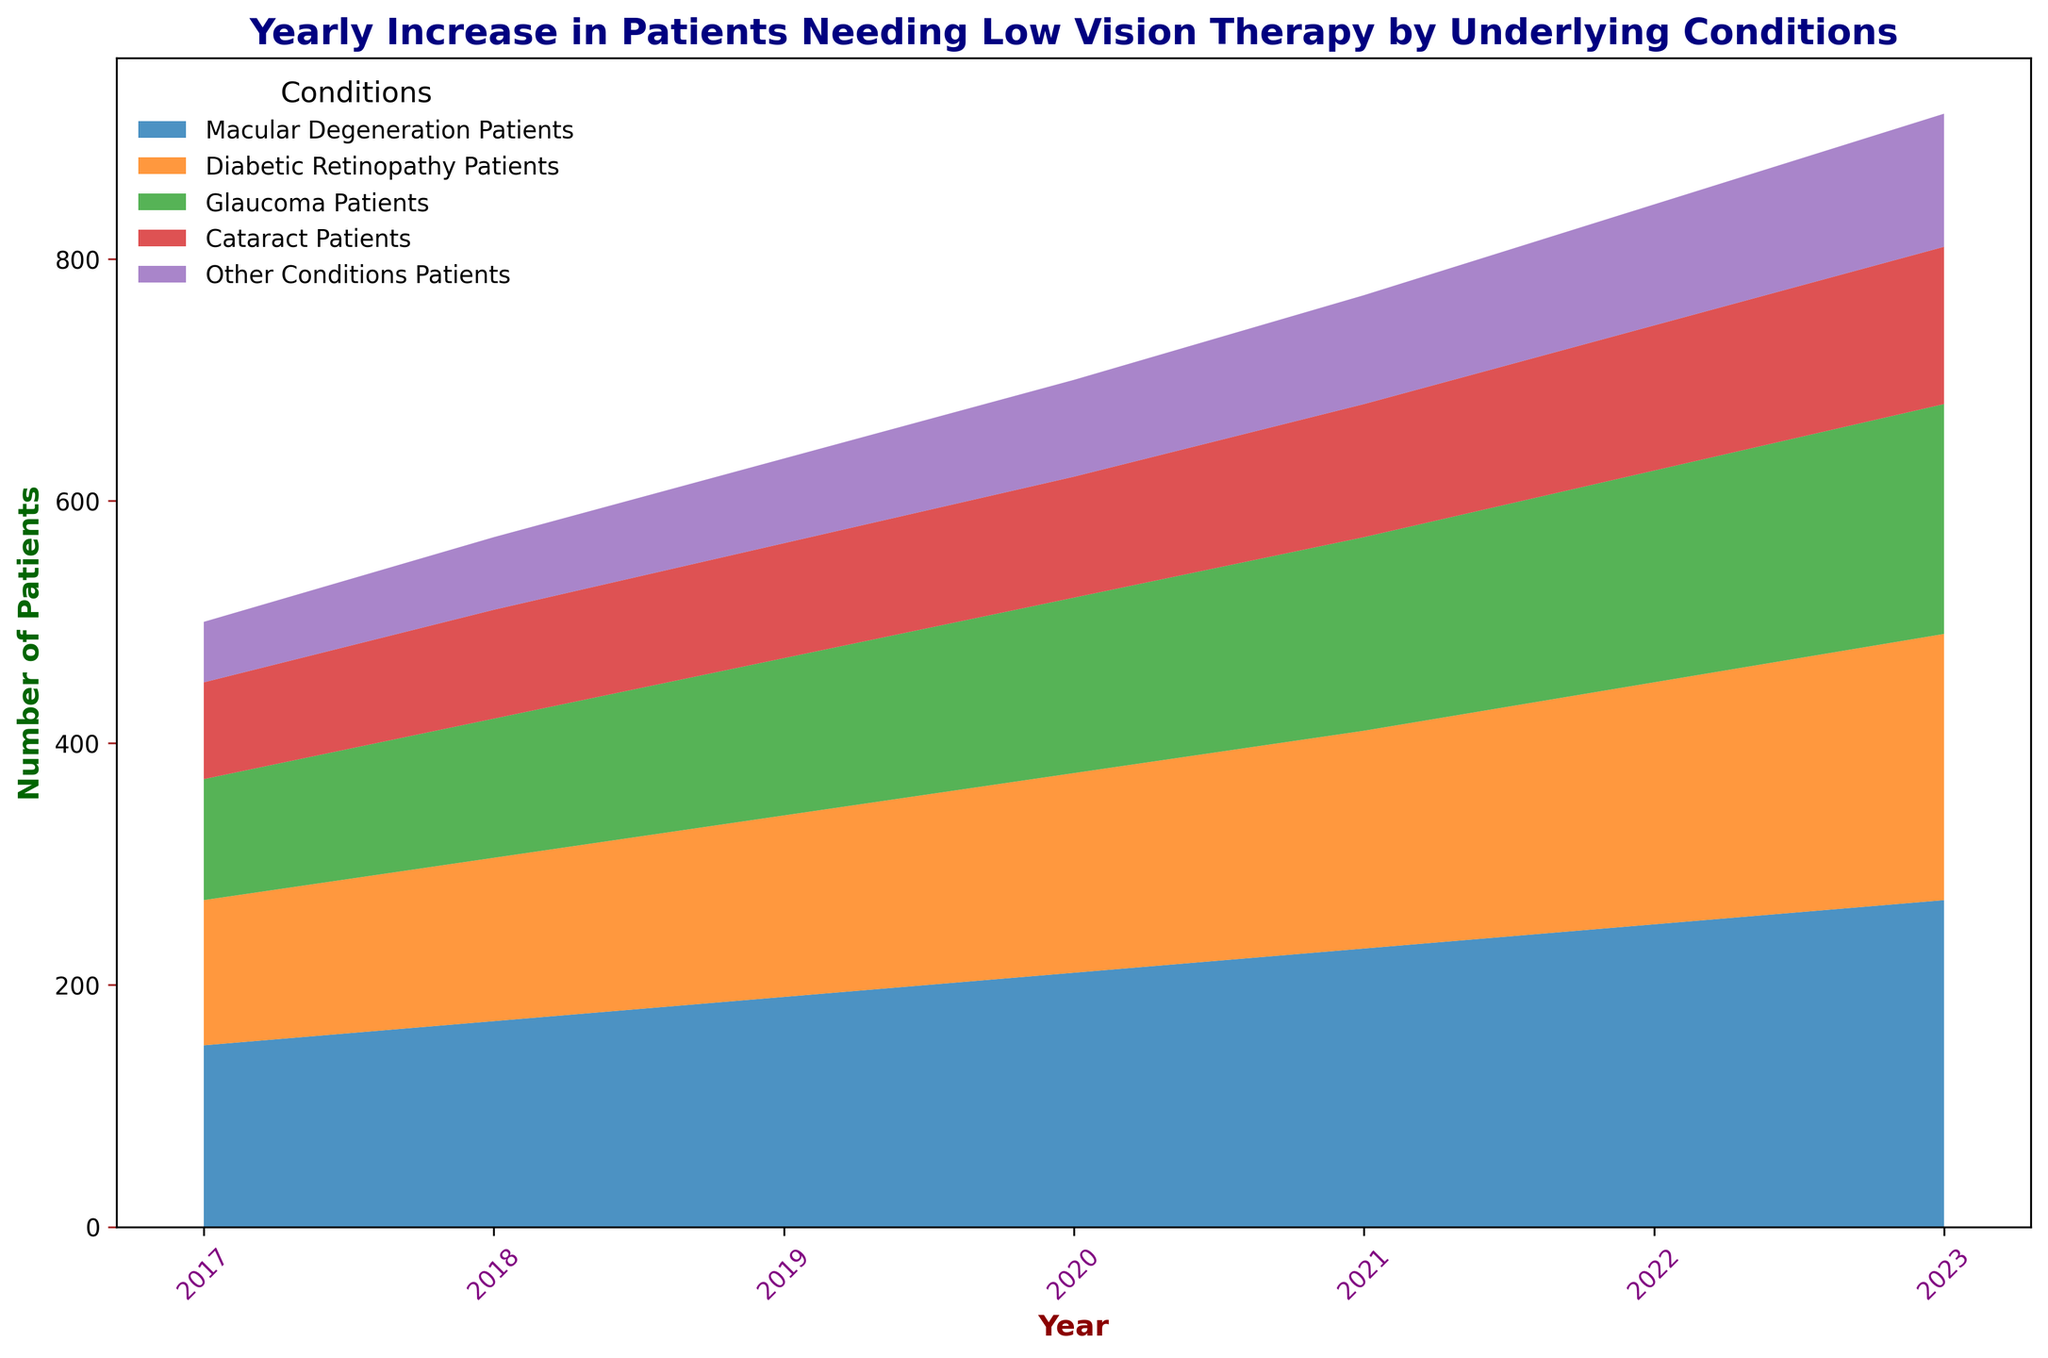What is the total number of patients needing low vision therapy in 2023 across all conditions? To find the total number in 2023, sum the patient numbers for each condition: Macular Degeneration (270) + Diabetic Retinopathy (220) + Glaucoma (190) + Cataract (130) + Other Conditions (110). So, the total is 270+220+190+130+110=920.
Answer: 920 Which condition saw the highest increase in the number of patients from 2017 to 2023? Calculate the difference in patient numbers for each condition between 2017 and 2023: Macular Degeneration (270-150=120), Diabetic Retinopathy (220-120=100), Glaucoma (190-100=90), Cataract (130-80=50), Other Conditions (110-50=60). The highest increase is for Macular Degeneration with 120 patients.
Answer: Macular Degeneration Between which years did the number of Cataract patients increase the most? Compare the yearly increments for Cataract patients: 2018 (90-80=10), 2019 (95-90=5), 2020 (100-95=5), 2021 (110-100=10), 2022 (120-110=10), 2023 (130-120=10). The greatest increase occurred between 2021 and 2022, and 2018 and 2021.
Answer: 2018-2019 and 2021-2022 What is the average number of Glaucoma patients from 2017 to 2023? Sum the numbers of Glaucoma patients from each year and divide by the number of years: (100+115+130+145+160+175+190)/7 = 1015/7 ≈ 145.
Answer: 145 By how much did the number of Diabetic Retinopathy Patients increase from 2018 to 2023? Subtract the number of Diabetic Retinopathy patients in 2018 (135) from the number in 2023 (220): 220-135=85.
Answer: 85 Which condition’s patient numbers remained the most stable over the years? Look at the differences year-to-year for each condition. Other Conditions have relatively smaller and consistent increases each year: (60-50=10), (70-60=10), (80-70=10), (90-80=10), (100-90=10), (110-100=10).
Answer: Other Conditions What is the percentage increase in Macular Degeneration patients from 2017 to 2023? Calculate the percentage increase: ((270-150)/150)*100 = (120/150)*100 = 80%.
Answer: 80% Compare the total number of patients needing low vision therapy in 2017 to that in 2022. Calculate the total number for each year: 2017 (150+120+100+80+50=500), 2022 (250+200+175+120+100=845). The difference is 845-500=345.
Answer: 345 Which condition had the smallest total number of patients in 2020? Check the patient numbers for each condition in 2020: Macular Degeneration (210), Diabetic Retinopathy (165), Glaucoma (145), Cataract (100), Other Conditions (80). Other Conditions had the smallest total number (80).
Answer: Other Conditions 